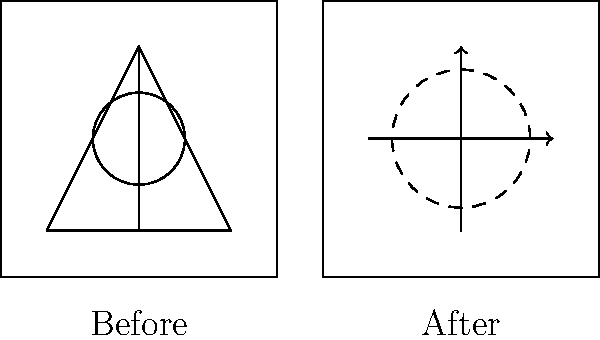In the process of reimagining the Greek mythological creature Medusa as a modern superhero, how would you illustrate her transformation from a snake-haired gorgon to a character with the power to control and manipulate electromagnetic fields? Use the before-and-after comparison provided to explain your approach. 1. Analyze the "Before" image:
   - Triangle shape represents Medusa's head
   - Circle represents her face
   - Vertical line represents her body
   - Squiggly lines on top represent snake hair

2. Consider Medusa's mythological abilities:
   - Ability to turn people to stone with her gaze

3. Translate mythological abilities to modern superpowers:
   - Petrification gaze → Control over electromagnetic fields

4. Analyze the "After" image:
   - Arrow pointing right represents forward movement/progress
   - Vertical arrow represents increased power/reach
   - Dashed circle represents expanded influence

5. Design the modernized superhero:
   - Replace snake hair with sleek, futuristic helmet
   - Add tech-enhanced suit with electromagnetic field generators
   - Incorporate visual cues for electromagnetic manipulation (e.g., glowing eyes, energy-emitting hands)

6. Illustrate new abilities:
   - Show electromagnetic waves emanating from the character
   - Depict objects being manipulated by invisible forces
   - Include visual representation of force fields or energy barriers

7. Maintain connection to original myth:
   - Use snake-like patterns in the costume design
   - Incorporate a stylized Medusa logo or emblem

8. Consider color scheme:
   - Shift from earthy, muted tones to electric blues and purples

9. Add modern context:
   - Include cityscape or technological background elements
Answer: Medusa: snake hair to EM-field helmet, stone gaze to electromagnetic control, mythic to modern aesthetic. 